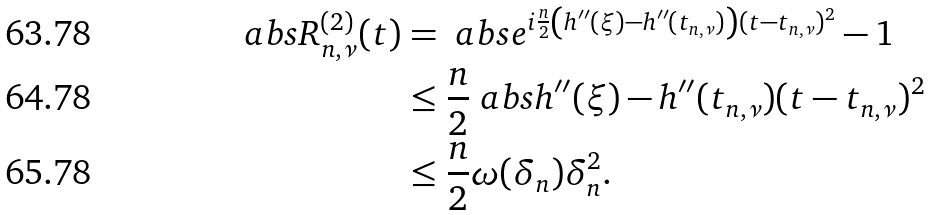<formula> <loc_0><loc_0><loc_500><loc_500>\ a b s { R _ { n , \nu } ^ { ( 2 ) } ( t ) } & = \ a b s { e ^ { i \frac { n } { 2 } \left ( h ^ { \prime \prime } ( \xi ) - h ^ { \prime \prime } ( t _ { n , \nu } ) \right ) ( t - t _ { n , \nu } ) ^ { 2 } } - 1 } \\ & \leq \frac { n } { 2 } \ a b s { h ^ { \prime \prime } ( \xi ) - h ^ { \prime \prime } ( t _ { n , \nu } ) } ( t - t _ { n , \nu } ) ^ { 2 } \\ & \leq \frac { n } { 2 } \omega ( \delta _ { n } ) \delta _ { n } ^ { 2 } .</formula> 